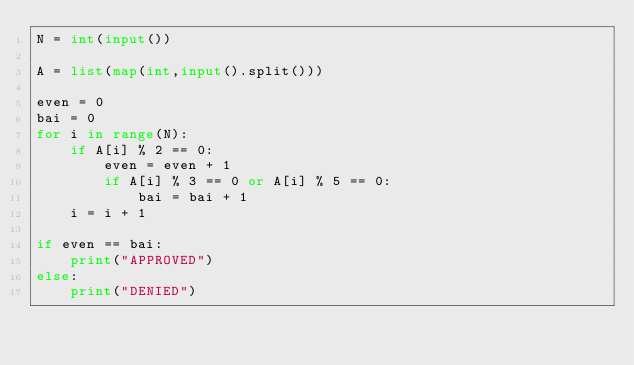<code> <loc_0><loc_0><loc_500><loc_500><_Python_>N = int(input())

A = list(map(int,input().split()))

even = 0
bai = 0
for i in range(N):
    if A[i] % 2 == 0:
        even = even + 1
        if A[i] % 3 == 0 or A[i] % 5 == 0:
            bai = bai + 1
    i = i + 1
    
if even == bai:
    print("APPROVED")
else:
    print("DENIED")
            </code> 